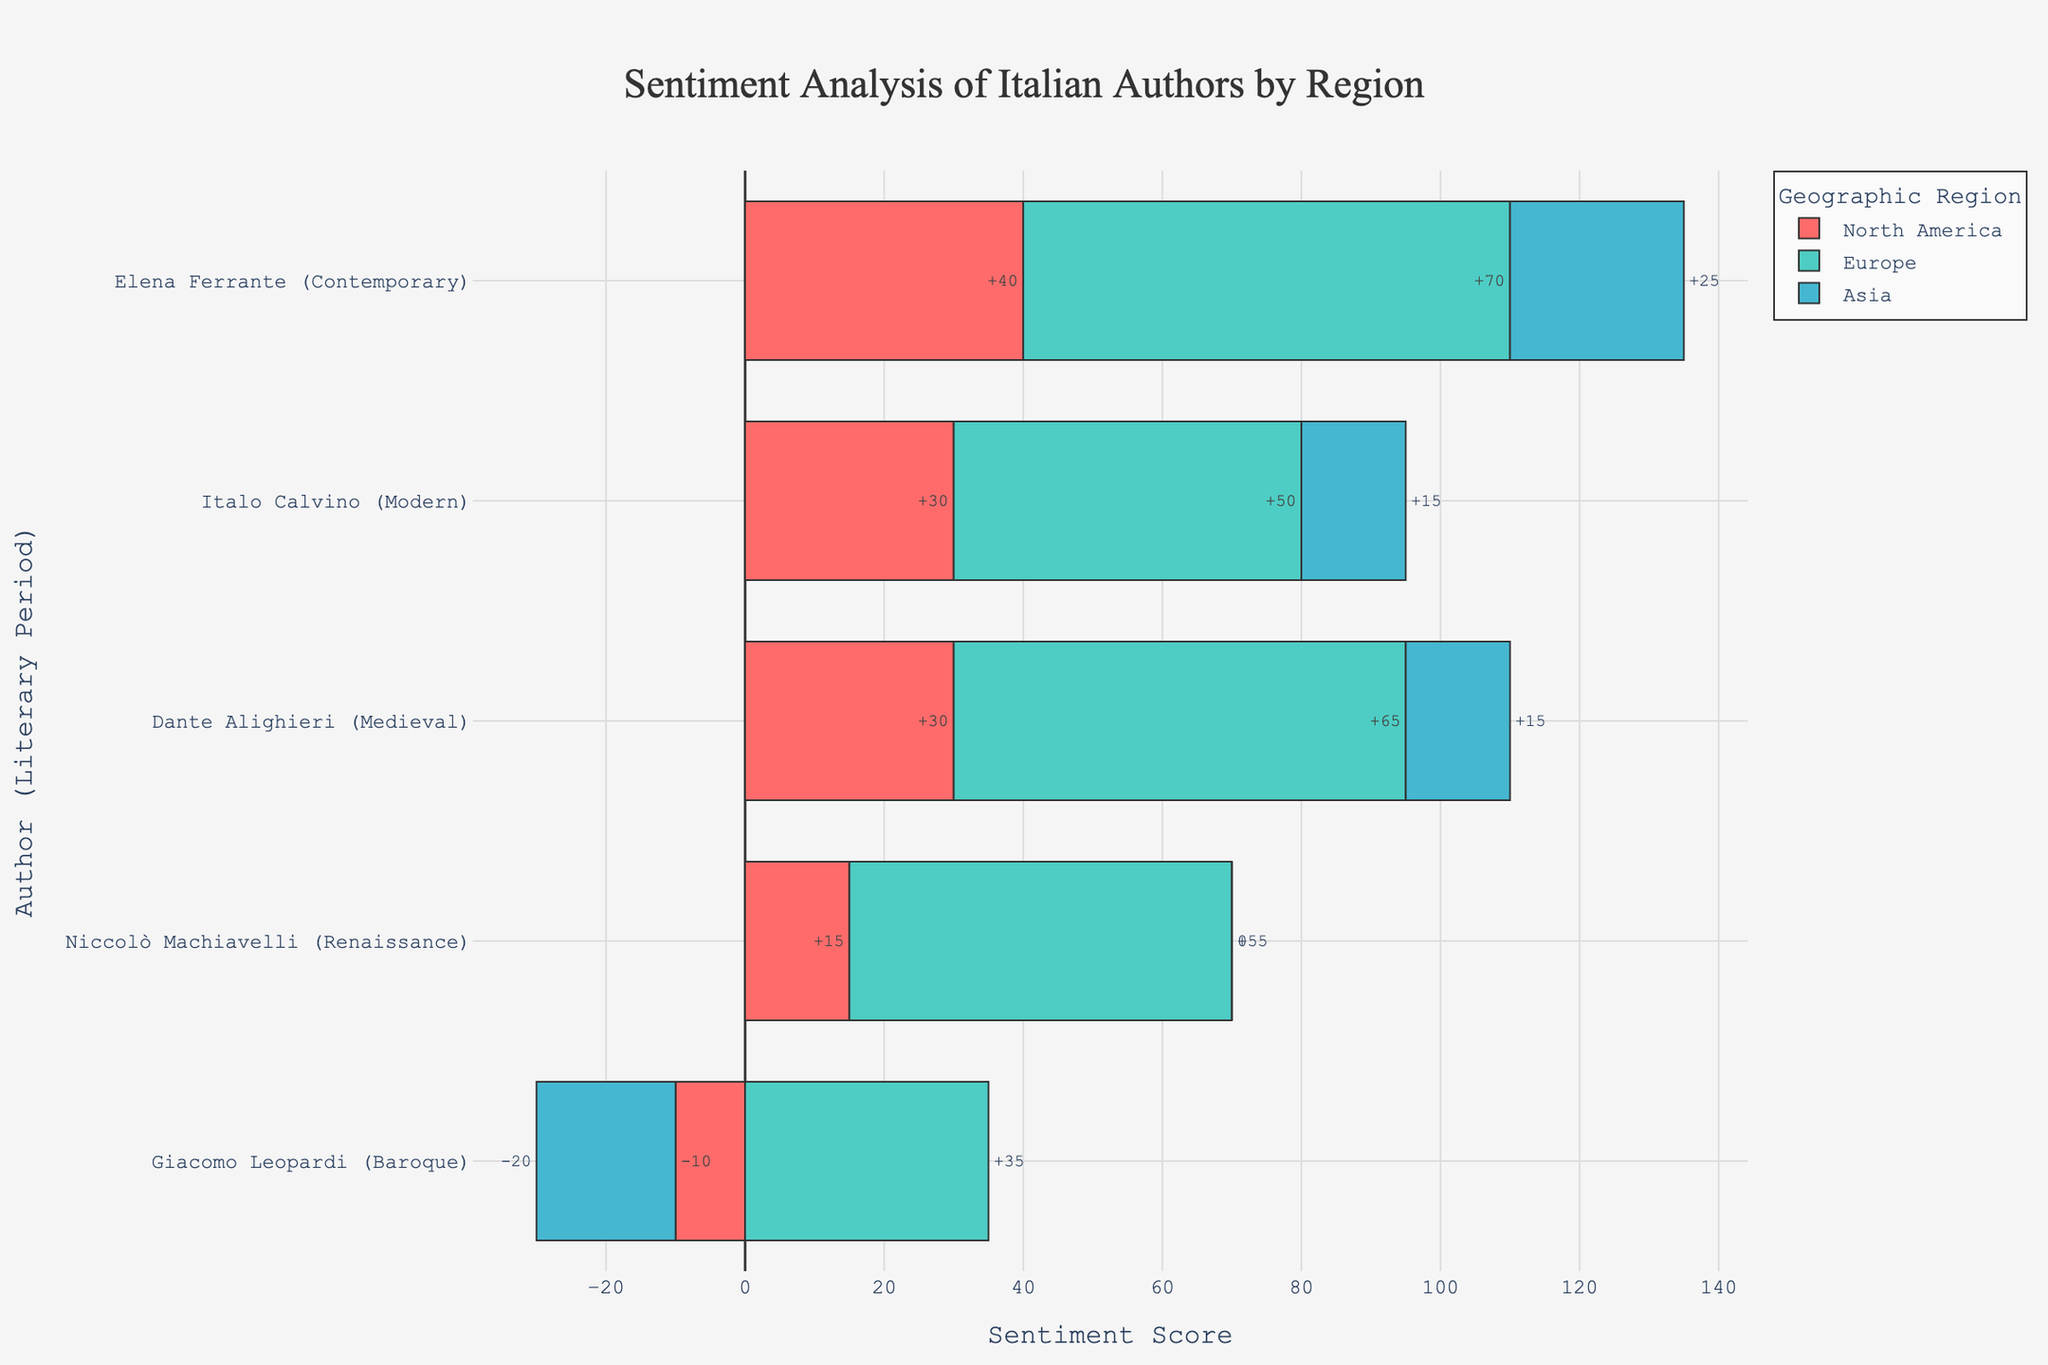Which author has the highest positive sentiment in Europe? We need to compare the positive sentiments of all authors in Europe. The author with the highest positive sentiment in Europe is Elena Ferrante with 75 positive sentiment.
Answer: Elena Ferrante Which author has the lowest sentiment score in Asia? We need to compare the sentiment scores in Asia, which are calculated as positive sentiment minus negative sentiment. Giacomo Leopardi, with a sentiment score of -20 (15 positive sentiment - 35 negative sentiment) has the lowest score.
Answer: Giacomo Leopardi What is the average sentiment score for Dante Alighieri across all regions? We calculate the sentiment scores for Dante Alighieri in each region: 30 in North America (40-10), 65 in Europe (70-5), 15 in Asia (30-15). The average sentiment score is (30 + 65 + 15) / 3 = 36.67.
Answer: 36.67 Compare the sentiment score of Italo Calvino between North America and Europe. Which region has the higher score and by how much? In North America, Italo Calvino's sentiment score is 30 (45-15). In Europe, it is 50 (60-10). Europe has the higher score with a difference of 50 - 30 = 20.
Answer: Europe, by 20 What is the total positive sentiment for authors from the Medieval period across all regions? We sum the positive sentiments for Dante Alighieri: 40 in North America, 70 in Europe, and 30 in Asia. The total is 40 + 70 + 30 = 140.
Answer: 140 Is Niccolò Machiavelli's sentiment score in North America greater than Elena Ferrante's sentiment score in Asia? Niccolò Machiavelli's sentiment score in North America is 15 (35-20). Elena Ferrante's sentiment score in Asia is 25 (40-15). Ferrante's score in Asia is greater.
Answer: No By how much does Elena Ferrante's positive sentiment in Europe exceed her positive sentiment in North America? Elena Ferrante's positive sentiment in Europe is 75 and in North America it is 50. The difference is 75 - 50 = 25.
Answer: 25 Which literary period has the highest average sentiment score in Europe? We calculate the average sentiment scores for each period in Europe: Medieval (65), Renaissance (55), Baroque (35), Modern (50), Contemporary (70). The Contemporary period has the highest average score.
Answer: Contemporary 